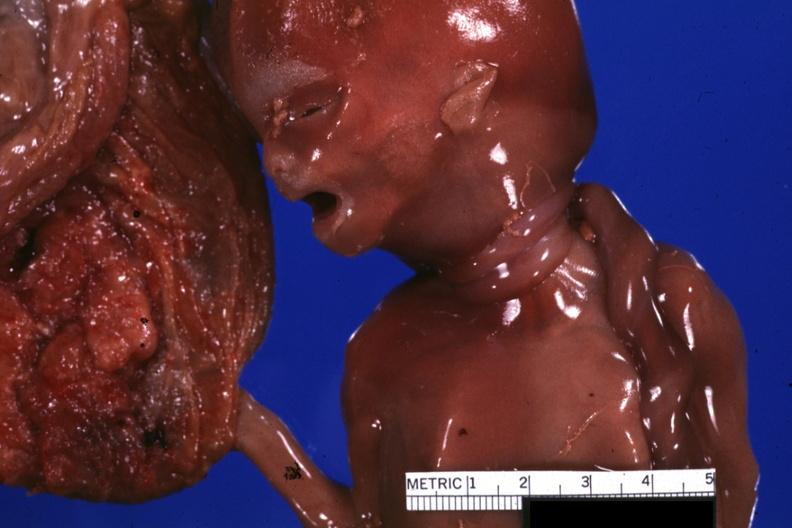does fibrinous peritonitis show close-up of two loops of umbilical cord around neck?
Answer the question using a single word or phrase. No 